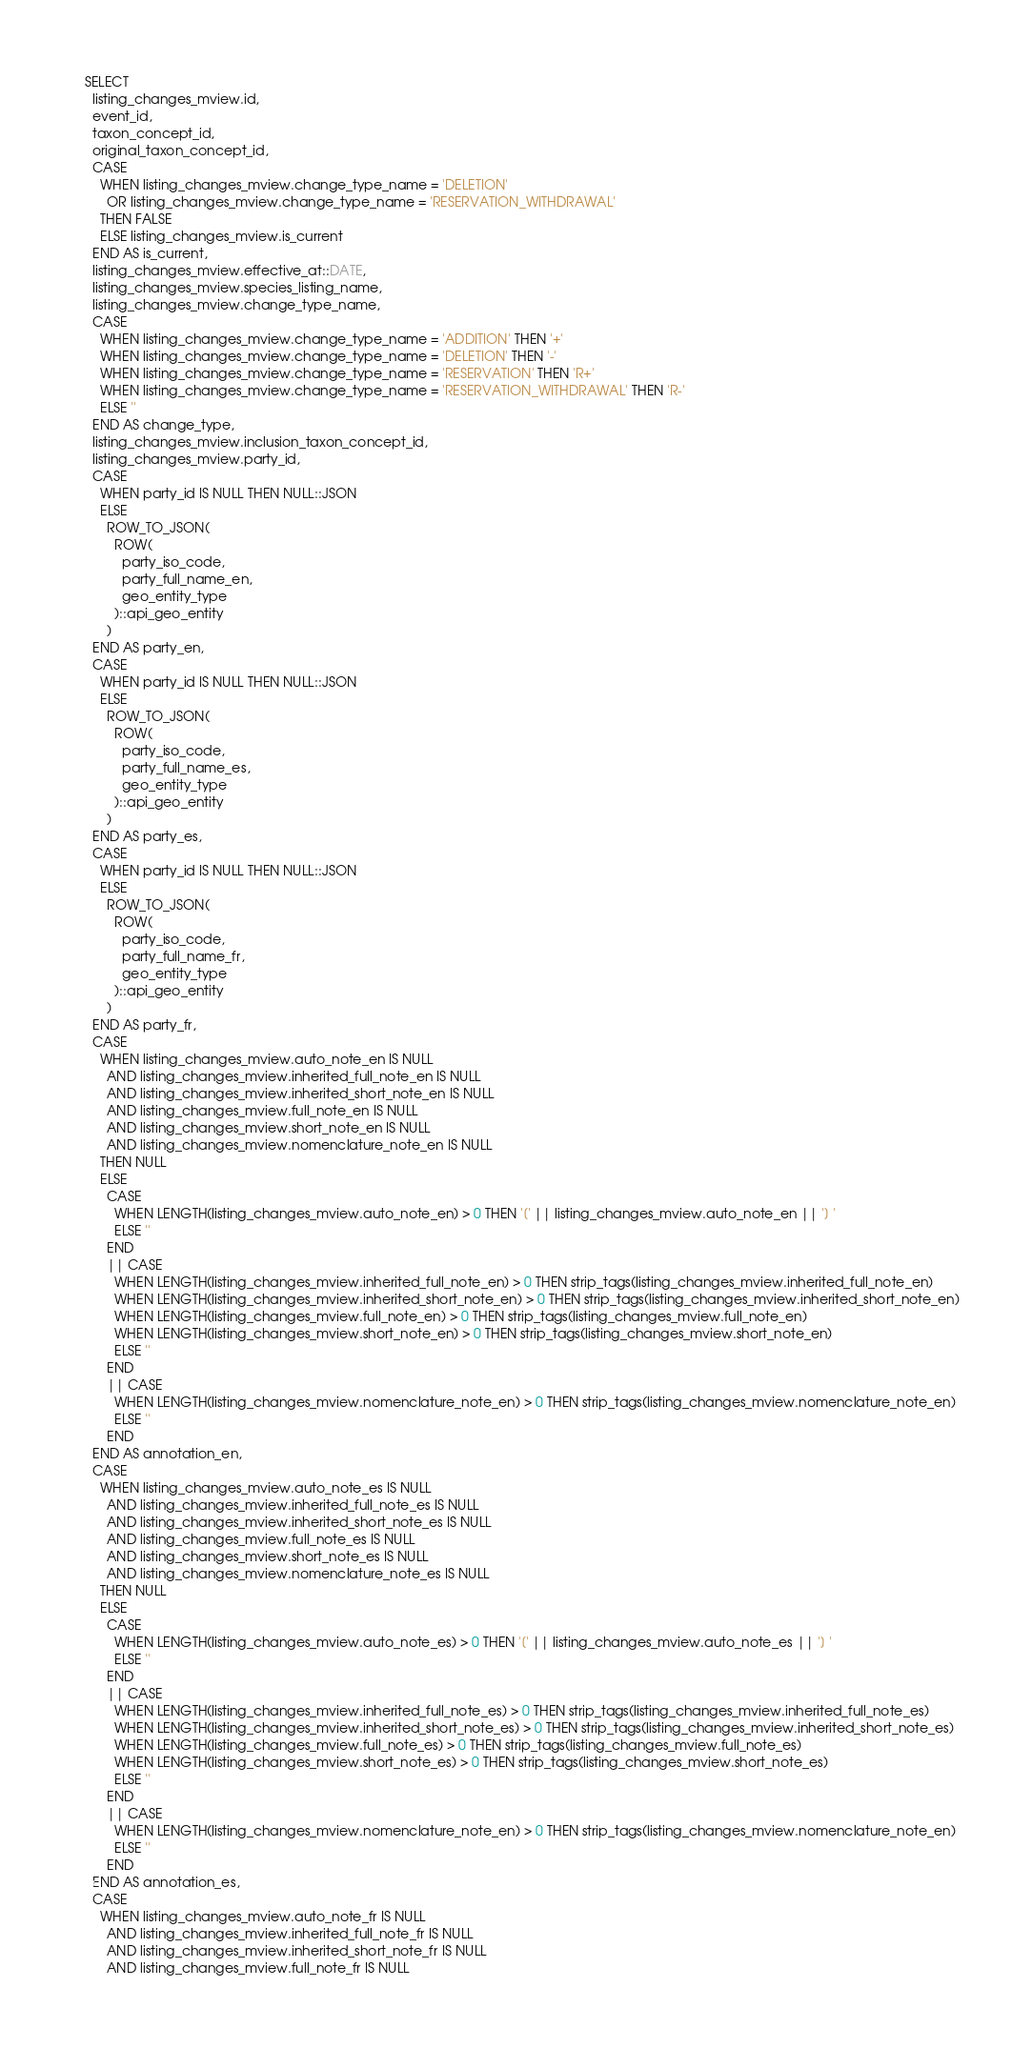Convert code to text. <code><loc_0><loc_0><loc_500><loc_500><_SQL_>SELECT
  listing_changes_mview.id,
  event_id,
  taxon_concept_id,
  original_taxon_concept_id,
  CASE
    WHEN listing_changes_mview.change_type_name = 'DELETION'
      OR listing_changes_mview.change_type_name = 'RESERVATION_WITHDRAWAL'
    THEN FALSE
    ELSE listing_changes_mview.is_current
  END AS is_current,
  listing_changes_mview.effective_at::DATE,
  listing_changes_mview.species_listing_name,
  listing_changes_mview.change_type_name,
  CASE
    WHEN listing_changes_mview.change_type_name = 'ADDITION' THEN '+'
    WHEN listing_changes_mview.change_type_name = 'DELETION' THEN '-'
    WHEN listing_changes_mview.change_type_name = 'RESERVATION' THEN 'R+'
    WHEN listing_changes_mview.change_type_name = 'RESERVATION_WITHDRAWAL' THEN 'R-'
    ELSE ''
  END AS change_type,
  listing_changes_mview.inclusion_taxon_concept_id,
  listing_changes_mview.party_id,
  CASE
    WHEN party_id IS NULL THEN NULL::JSON
    ELSE
      ROW_TO_JSON(
        ROW(
          party_iso_code,
          party_full_name_en,
          geo_entity_type
        )::api_geo_entity
      )
  END AS party_en,
  CASE
    WHEN party_id IS NULL THEN NULL::JSON
    ELSE
      ROW_TO_JSON(
        ROW(
          party_iso_code,
          party_full_name_es,
          geo_entity_type
        )::api_geo_entity
      )
  END AS party_es,
  CASE
    WHEN party_id IS NULL THEN NULL::JSON
    ELSE
      ROW_TO_JSON(
        ROW(
          party_iso_code,
          party_full_name_fr,
          geo_entity_type
        )::api_geo_entity
      )
  END AS party_fr,
  CASE
    WHEN listing_changes_mview.auto_note_en IS NULL
      AND listing_changes_mview.inherited_full_note_en IS NULL
      AND listing_changes_mview.inherited_short_note_en IS NULL
      AND listing_changes_mview.full_note_en IS NULL
      AND listing_changes_mview.short_note_en IS NULL
      AND listing_changes_mview.nomenclature_note_en IS NULL
    THEN NULL
    ELSE
      CASE
        WHEN LENGTH(listing_changes_mview.auto_note_en) > 0 THEN '[' || listing_changes_mview.auto_note_en || '] '
        ELSE ''
      END
      || CASE
        WHEN LENGTH(listing_changes_mview.inherited_full_note_en) > 0 THEN strip_tags(listing_changes_mview.inherited_full_note_en)
        WHEN LENGTH(listing_changes_mview.inherited_short_note_en) > 0 THEN strip_tags(listing_changes_mview.inherited_short_note_en)
        WHEN LENGTH(listing_changes_mview.full_note_en) > 0 THEN strip_tags(listing_changes_mview.full_note_en)
        WHEN LENGTH(listing_changes_mview.short_note_en) > 0 THEN strip_tags(listing_changes_mview.short_note_en)
        ELSE ''
      END
      || CASE
        WHEN LENGTH(listing_changes_mview.nomenclature_note_en) > 0 THEN strip_tags(listing_changes_mview.nomenclature_note_en)
        ELSE ''
      END
  END AS annotation_en,
  CASE
    WHEN listing_changes_mview.auto_note_es IS NULL
      AND listing_changes_mview.inherited_full_note_es IS NULL
      AND listing_changes_mview.inherited_short_note_es IS NULL
      AND listing_changes_mview.full_note_es IS NULL
      AND listing_changes_mview.short_note_es IS NULL
      AND listing_changes_mview.nomenclature_note_es IS NULL
    THEN NULL
    ELSE
      CASE
        WHEN LENGTH(listing_changes_mview.auto_note_es) > 0 THEN '[' || listing_changes_mview.auto_note_es || '] '
        ELSE ''
      END
      || CASE
        WHEN LENGTH(listing_changes_mview.inherited_full_note_es) > 0 THEN strip_tags(listing_changes_mview.inherited_full_note_es)
        WHEN LENGTH(listing_changes_mview.inherited_short_note_es) > 0 THEN strip_tags(listing_changes_mview.inherited_short_note_es)
        WHEN LENGTH(listing_changes_mview.full_note_es) > 0 THEN strip_tags(listing_changes_mview.full_note_es)
        WHEN LENGTH(listing_changes_mview.short_note_es) > 0 THEN strip_tags(listing_changes_mview.short_note_es)
        ELSE ''
      END
      || CASE
        WHEN LENGTH(listing_changes_mview.nomenclature_note_en) > 0 THEN strip_tags(listing_changes_mview.nomenclature_note_en)
        ELSE ''
      END
  END AS annotation_es,
  CASE
    WHEN listing_changes_mview.auto_note_fr IS NULL
      AND listing_changes_mview.inherited_full_note_fr IS NULL
      AND listing_changes_mview.inherited_short_note_fr IS NULL
      AND listing_changes_mview.full_note_fr IS NULL</code> 